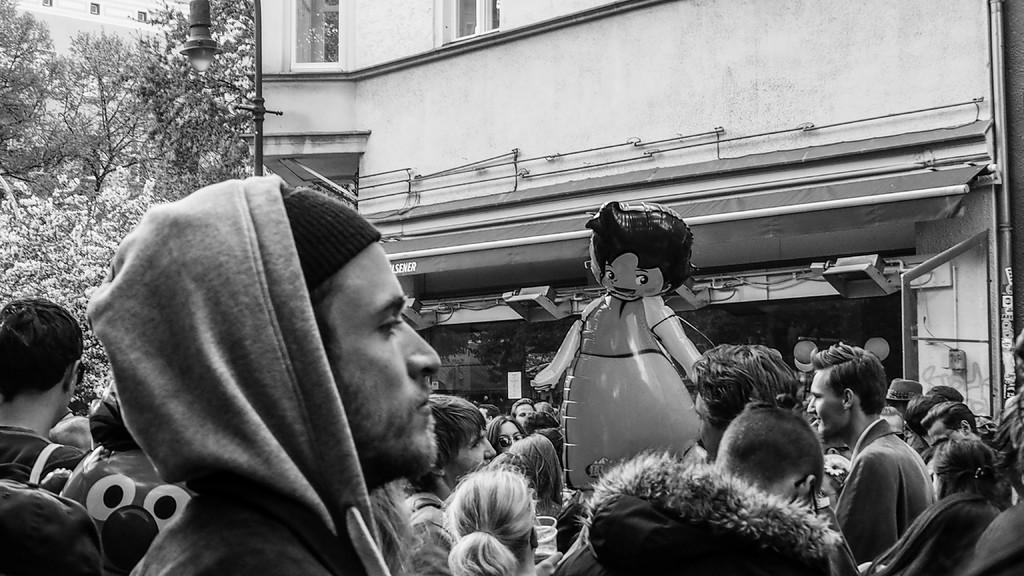What is the color scheme of the image? The image is black and white. What can be seen in the image? There is a group of people and a balloon in the image. What is visible in the background of the image? There is a building with windows and trees in the background of the image. What type of bottle can be seen in the image? There is no bottle present in the image. How many matches are visible in the image? There are no matches visible in the image. 